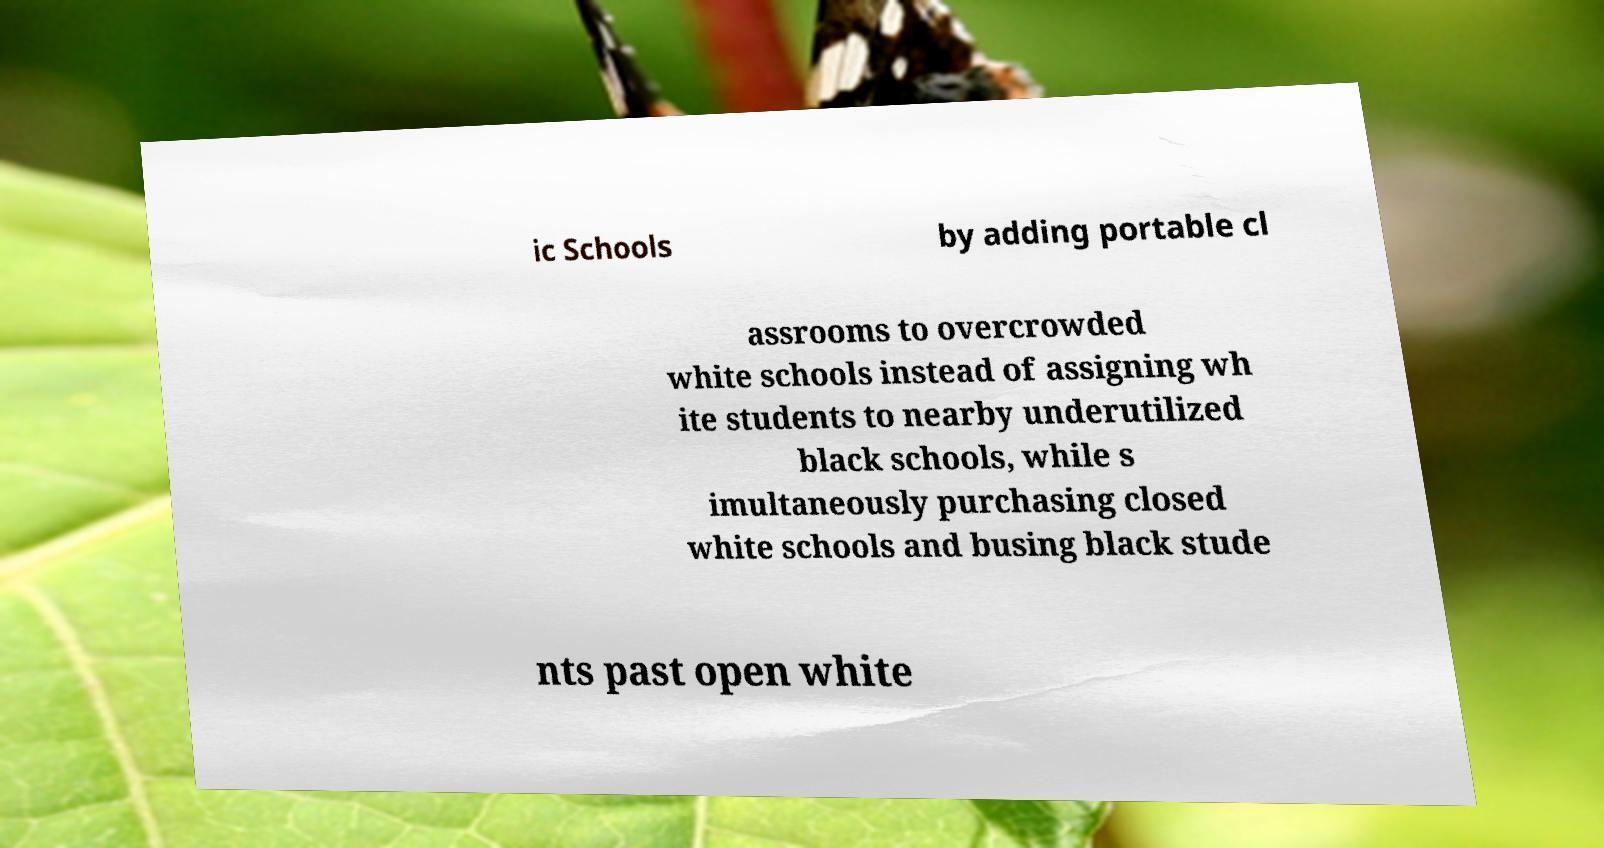There's text embedded in this image that I need extracted. Can you transcribe it verbatim? ic Schools by adding portable cl assrooms to overcrowded white schools instead of assigning wh ite students to nearby underutilized black schools, while s imultaneously purchasing closed white schools and busing black stude nts past open white 